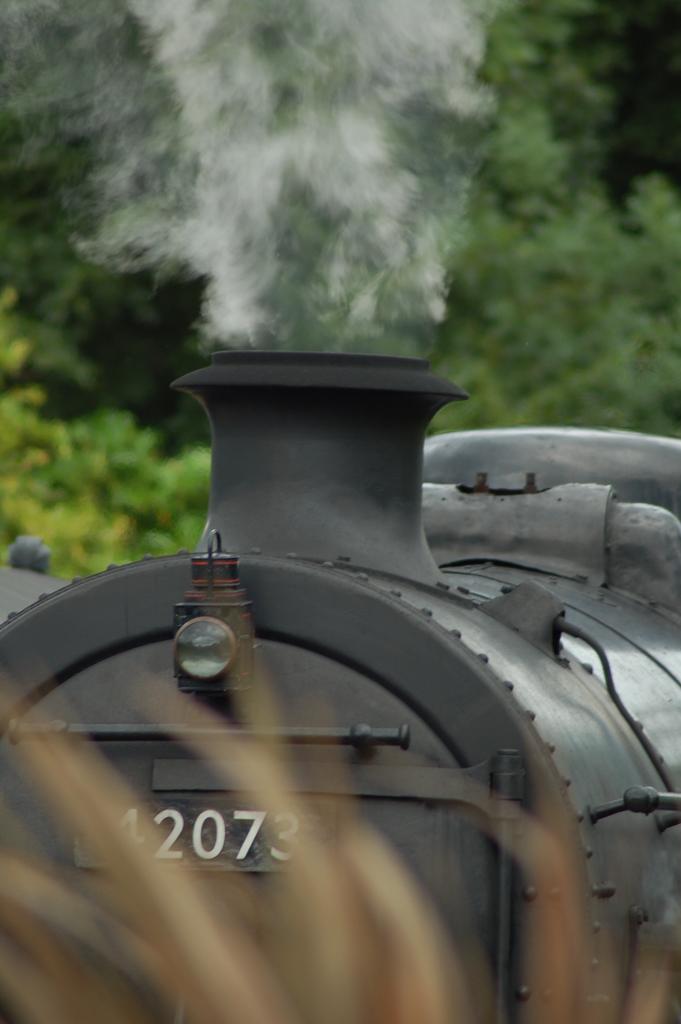In one or two sentences, can you explain what this image depicts? At the bottom of this image, there is grass. In the background, there are white color numbers on a black color train, which is emitting smoke and there are trees. 